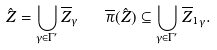<formula> <loc_0><loc_0><loc_500><loc_500>\hat { Z } = \bigcup _ { \gamma \in \Gamma ^ { \prime } } \overline { Z } _ { \gamma } \quad \overline { \pi } ( \hat { Z } ) \subseteq \bigcup _ { \gamma \in \Gamma ^ { \prime } } { \overline { Z } _ { 1 } } _ { \gamma } .</formula> 